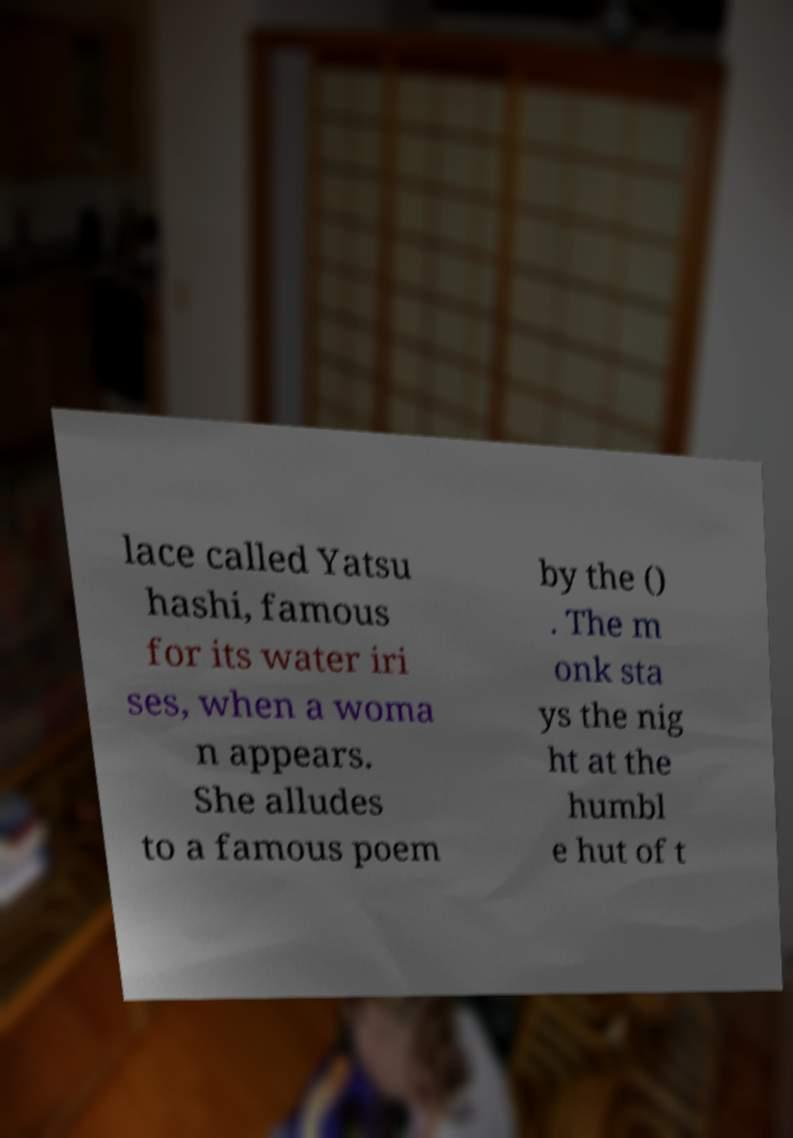For documentation purposes, I need the text within this image transcribed. Could you provide that? lace called Yatsu hashi, famous for its water iri ses, when a woma n appears. She alludes to a famous poem by the () . The m onk sta ys the nig ht at the humbl e hut of t 